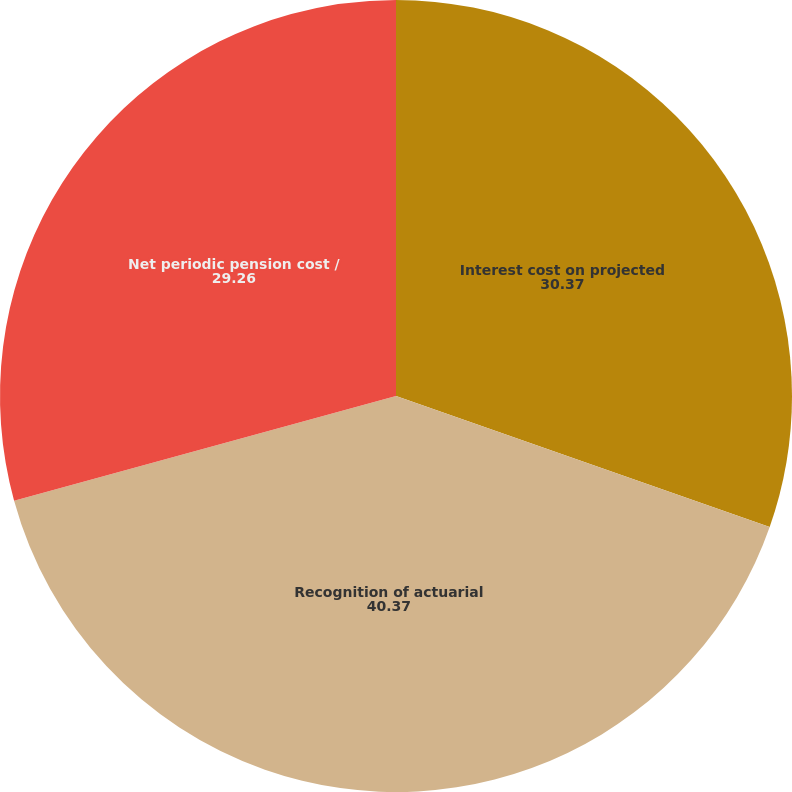Convert chart to OTSL. <chart><loc_0><loc_0><loc_500><loc_500><pie_chart><fcel>Interest cost on projected<fcel>Recognition of actuarial<fcel>Net periodic pension cost /<nl><fcel>30.37%<fcel>40.37%<fcel>29.26%<nl></chart> 